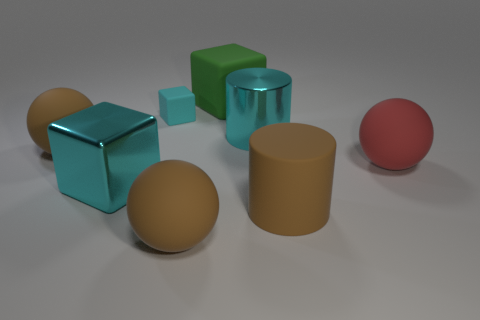Subtract all large brown balls. How many balls are left? 1 Subtract 2 blocks. How many blocks are left? 1 Subtract all red balls. How many balls are left? 2 Subtract all blocks. How many objects are left? 5 Add 8 red matte things. How many red matte things exist? 9 Add 1 metallic balls. How many objects exist? 9 Subtract 0 purple cylinders. How many objects are left? 8 Subtract all yellow cylinders. Subtract all gray balls. How many cylinders are left? 2 Subtract all blue blocks. How many yellow cylinders are left? 0 Subtract all tiny gray matte balls. Subtract all big red objects. How many objects are left? 7 